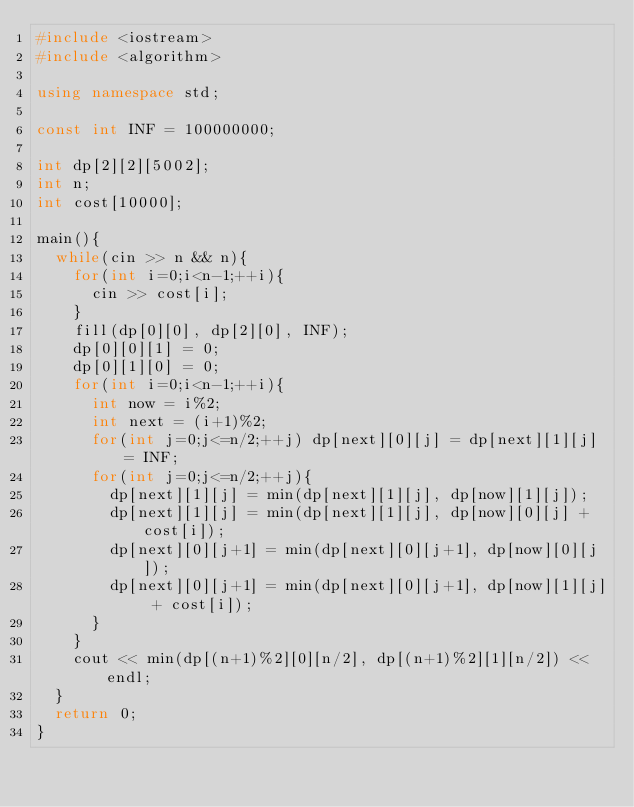<code> <loc_0><loc_0><loc_500><loc_500><_C++_>#include <iostream>
#include <algorithm>

using namespace std;

const int INF = 100000000;

int dp[2][2][5002];
int n;
int cost[10000];

main(){
  while(cin >> n && n){
    for(int i=0;i<n-1;++i){
      cin >> cost[i];
    }
    fill(dp[0][0], dp[2][0], INF);
    dp[0][0][1] = 0;
    dp[0][1][0] = 0;
    for(int i=0;i<n-1;++i){
      int now = i%2;
      int next = (i+1)%2;
      for(int j=0;j<=n/2;++j) dp[next][0][j] = dp[next][1][j] = INF;
      for(int j=0;j<=n/2;++j){
        dp[next][1][j] = min(dp[next][1][j], dp[now][1][j]);
        dp[next][1][j] = min(dp[next][1][j], dp[now][0][j] + cost[i]);
        dp[next][0][j+1] = min(dp[next][0][j+1], dp[now][0][j]);
        dp[next][0][j+1] = min(dp[next][0][j+1], dp[now][1][j] + cost[i]);
      }
    }
    cout << min(dp[(n+1)%2][0][n/2], dp[(n+1)%2][1][n/2]) << endl;
  }
  return 0;
}</code> 